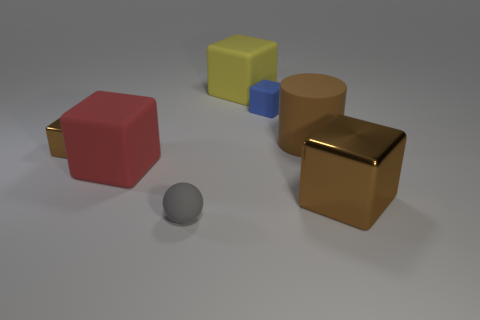Subtract all brown cubes. How many cubes are left? 3 Subtract all purple cylinders. How many brown blocks are left? 2 Subtract all red blocks. How many blocks are left? 4 Subtract all purple cubes. Subtract all purple spheres. How many cubes are left? 5 Add 2 cyan metal spheres. How many objects exist? 9 Subtract all blocks. How many objects are left? 2 Add 6 small objects. How many small objects are left? 9 Add 1 tiny green shiny objects. How many tiny green shiny objects exist? 1 Subtract 1 red blocks. How many objects are left? 6 Subtract all gray matte objects. Subtract all big purple cylinders. How many objects are left? 6 